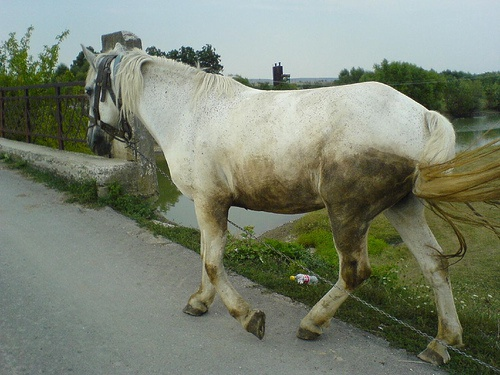Describe the objects in this image and their specific colors. I can see horse in lightblue, darkgray, olive, lightgray, and black tones and bottle in lightblue, darkgray, gray, black, and lightgray tones in this image. 